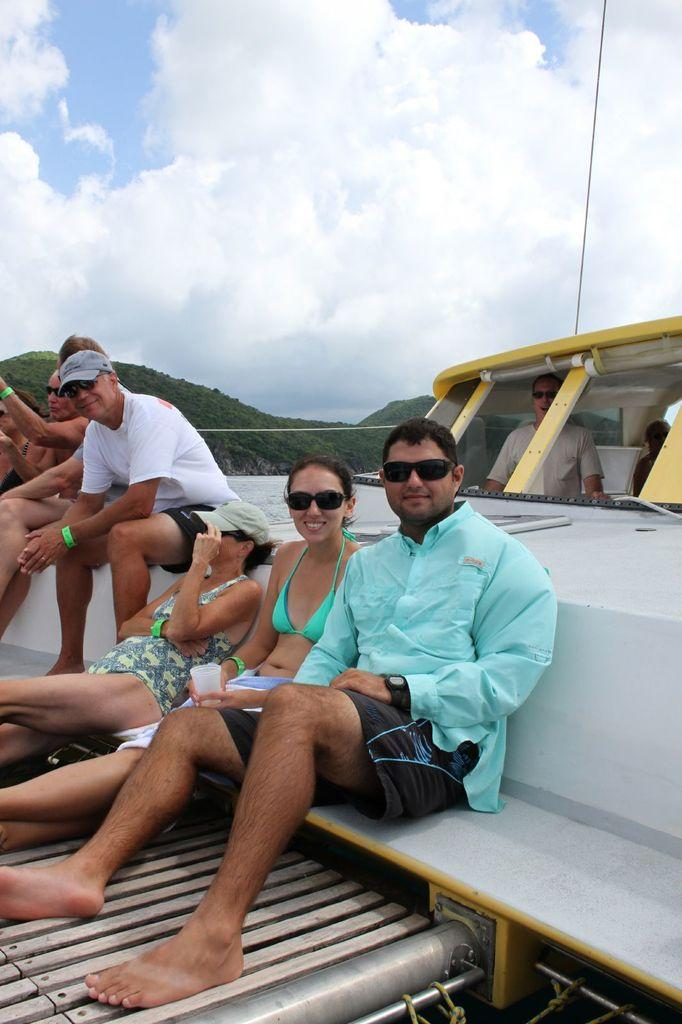What are the people in the image doing? The people in the image are sitting. What is visible at the top of the image? The sky is visible at the top of the image. How would you describe the sky in the image? The sky is cloudy in the image. What minute detail can be seen in the image that is unrelated to the people or the sky? There is no specific minute detail mentioned in the facts provided, so it is not possible to answer that question. 